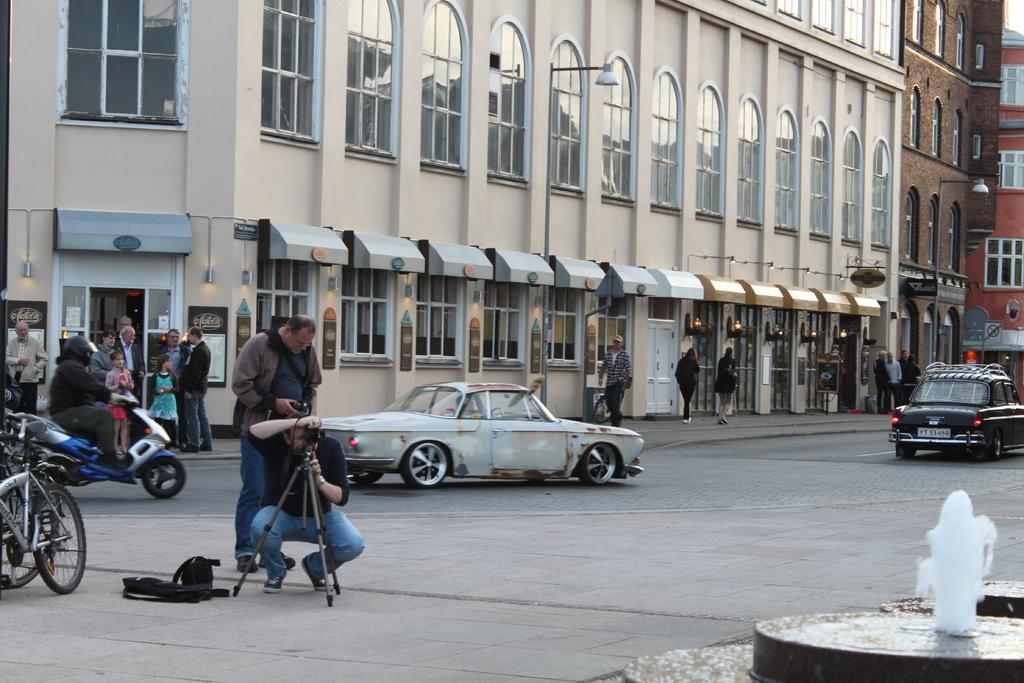What is the person in the image holding? The person in the image is holding a camera. How is the camera positioned in the image? The camera is on a tripod stand. What can be seen in the foreground of the image? There is a fountain in the image. What is happening in the image involving a group of people? There is a group of people standing in the image. What can be seen in the background of the image? Vehicles and buildings are visible in the background of the image. What type of milk is being used to teach the fireman in the image? There is no milk, fireman, or teaching activity present in the image. 